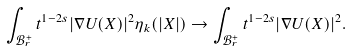Convert formula to latex. <formula><loc_0><loc_0><loc_500><loc_500>\int _ { \mathcal { B } _ { r } ^ { + } } t ^ { 1 - 2 s } | \nabla U ( X ) | ^ { 2 } \eta _ { k } ( | X | ) \to \int _ { \mathcal { B } _ { r } ^ { + } } t ^ { 1 - 2 s } | \nabla U ( X ) | ^ { 2 } .</formula> 